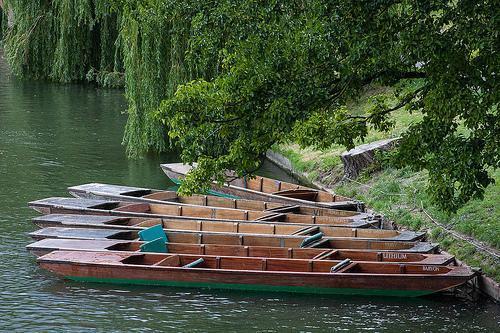How many boats are there?
Give a very brief answer. 7. How many boats?
Give a very brief answer. 7. How many boats on the water?
Give a very brief answer. 7. 